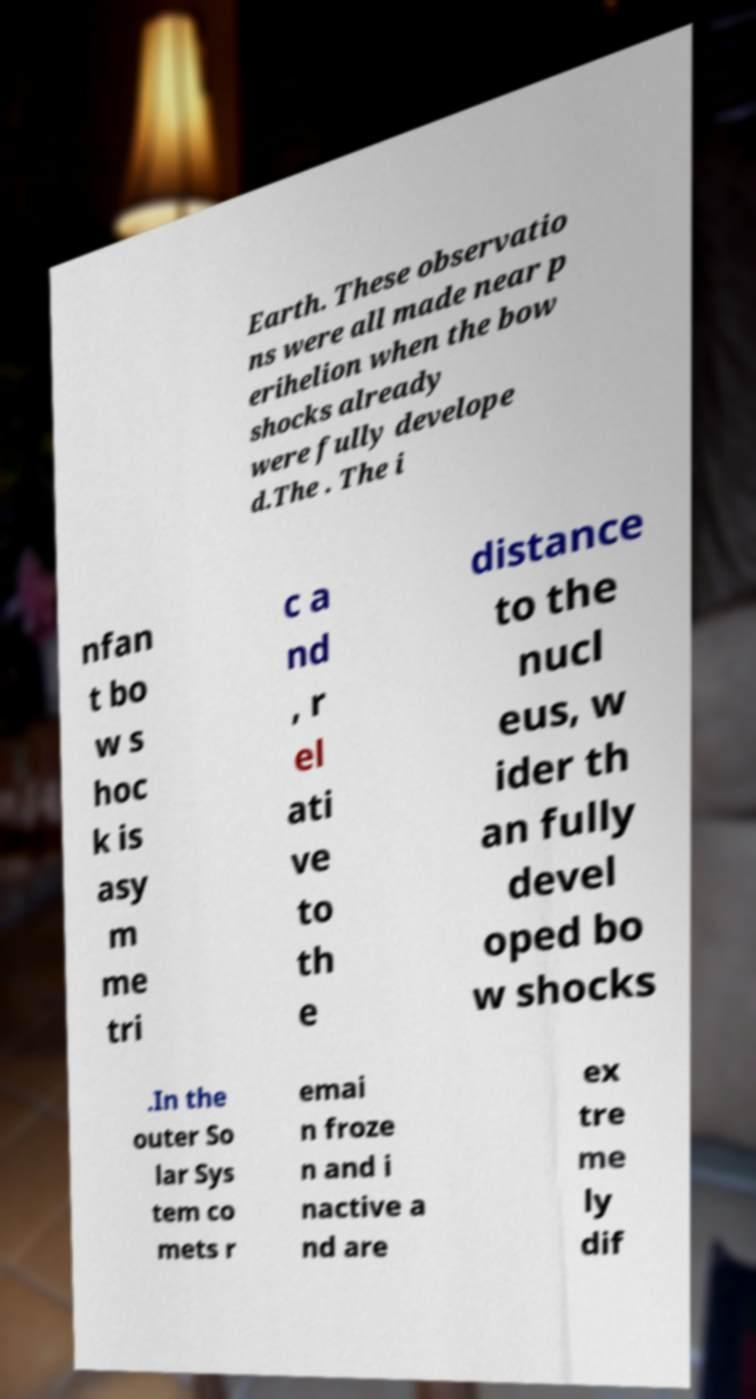Can you read and provide the text displayed in the image?This photo seems to have some interesting text. Can you extract and type it out for me? Earth. These observatio ns were all made near p erihelion when the bow shocks already were fully develope d.The . The i nfan t bo w s hoc k is asy m me tri c a nd , r el ati ve to th e distance to the nucl eus, w ider th an fully devel oped bo w shocks .In the outer So lar Sys tem co mets r emai n froze n and i nactive a nd are ex tre me ly dif 